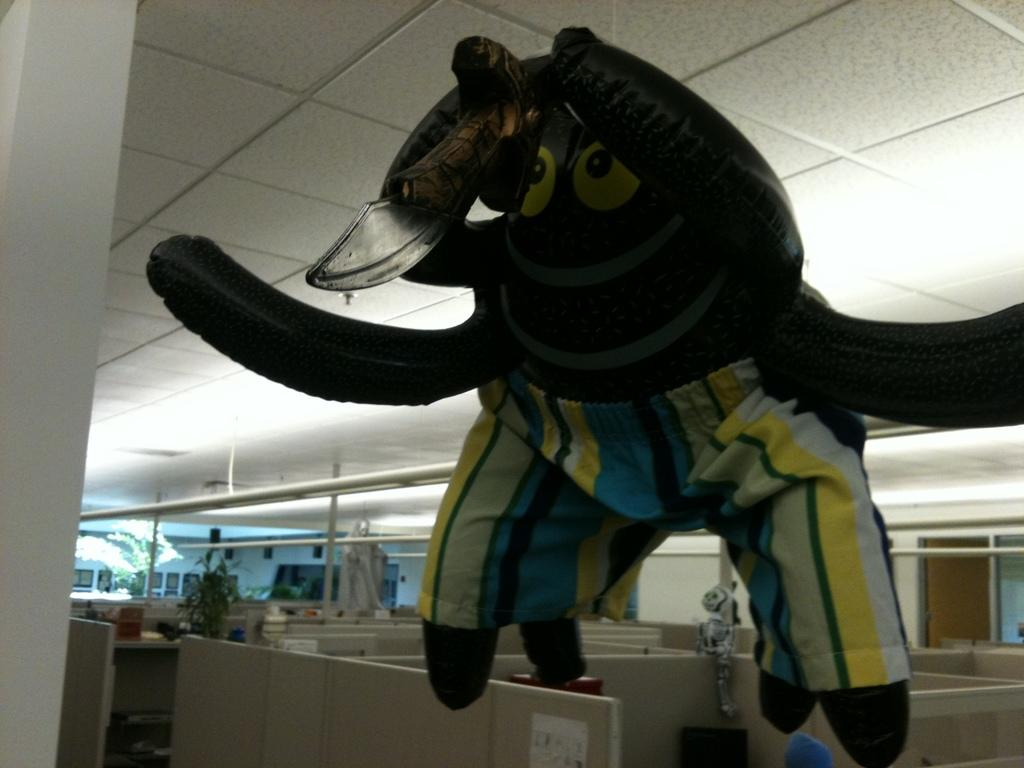What type of animal is in the image? The specific type of animal cannot be determined from the provided facts. What structure is visible in the image? There is a roof in the image. What time is displayed on the clock in the image? There is no clock present in the image, so it is not possible to determine the time. 